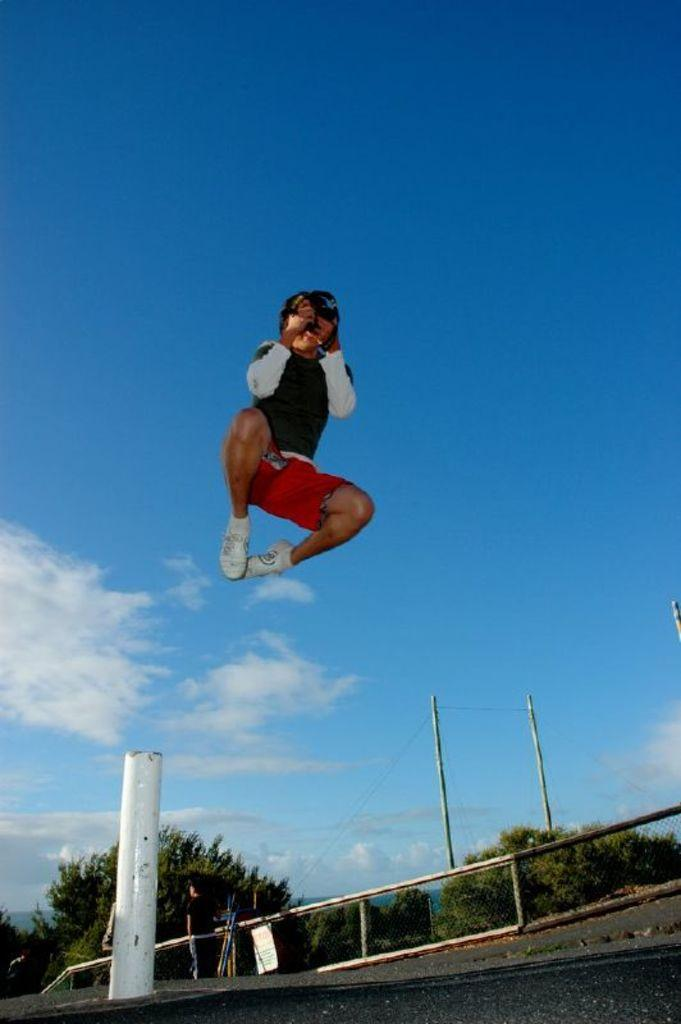What is the person in the image holding? The person in the image is holding a camera. What can be seen in the background of the image? There is a fence, poles, wires, a group of trees, and a pathway visible in the background. What is the condition of the sky in the image? The sky is visible in the image and appears cloudy. Where is the playground located in the image? There is no playground present in the image. Why is the person in the image crying? There is no indication in the image that the person is crying. 